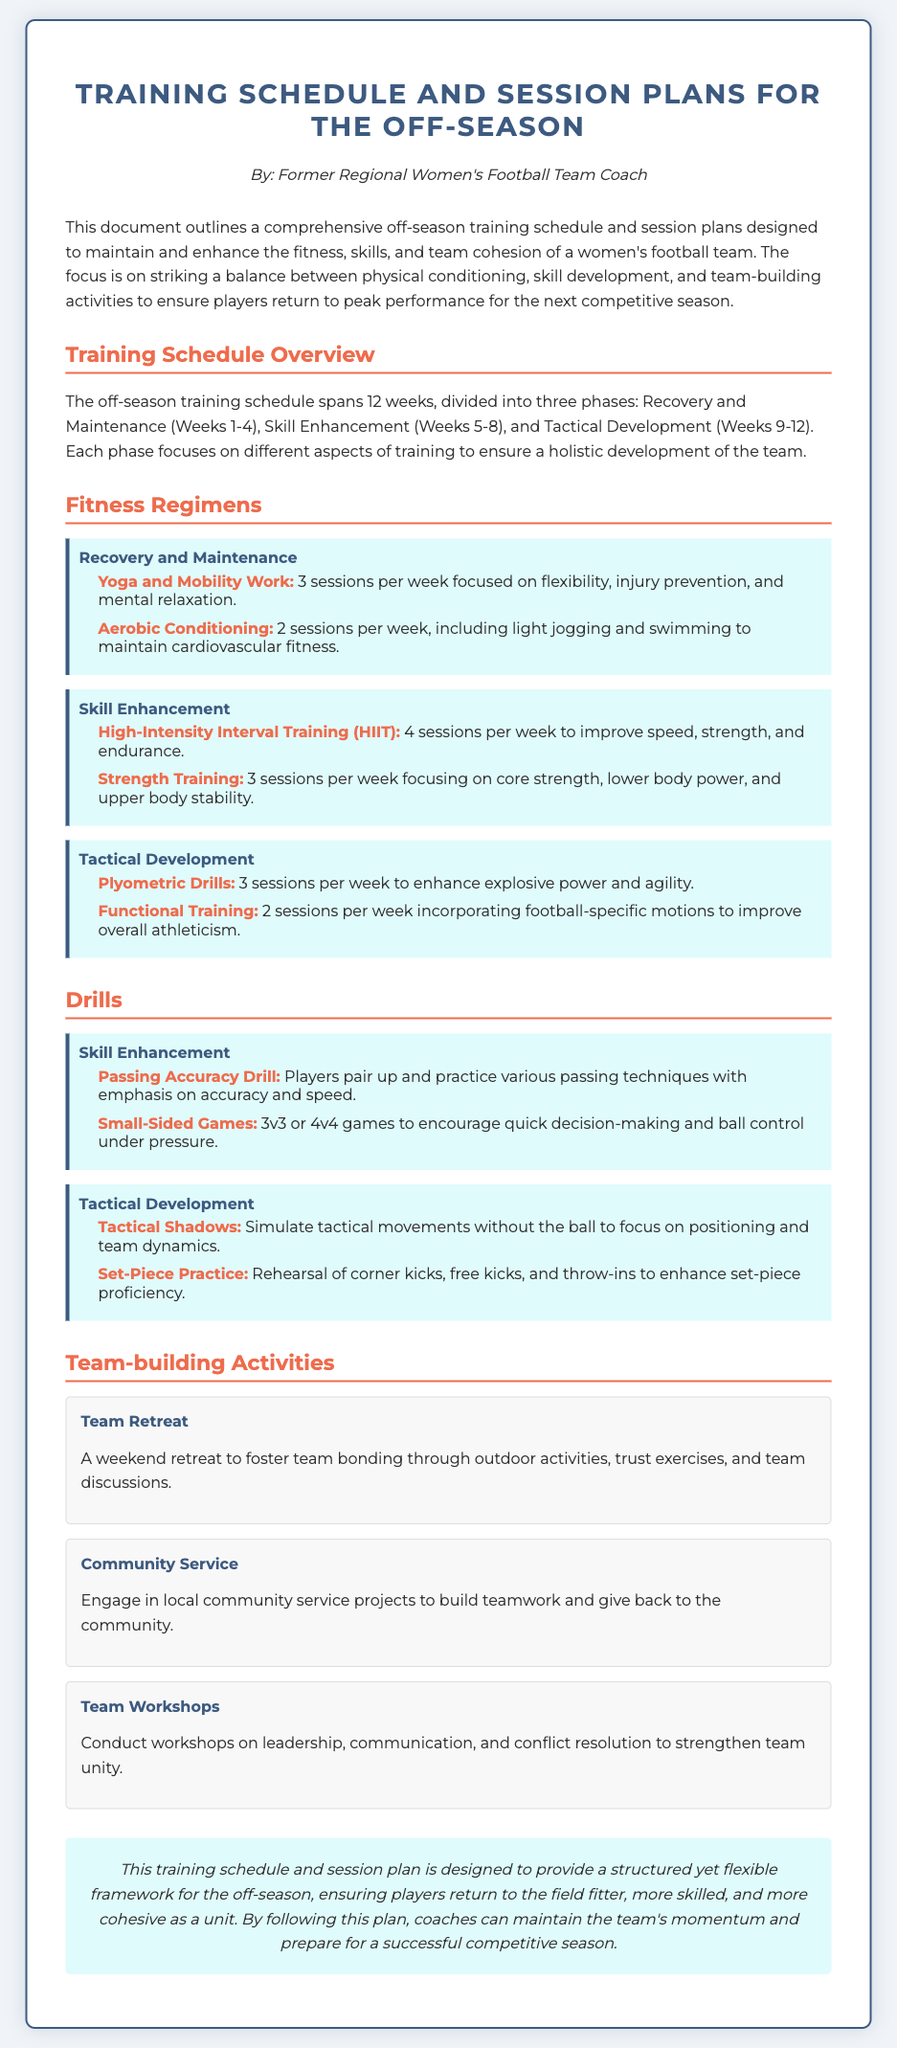What is the title of the document? The title of the document is stated at the top of the rendered document.
Answer: Training Schedule and Session Plans for the Off-Season Who authored the document? The author is mentioned below the title, indicating their background.
Answer: Former Regional Women's Football Team Coach How many phases are in the training schedule? The document outlines the training schedule split into three phases.
Answer: 3 What is the focus of the 'Recovery and Maintenance' phase? The document specifies the activities covered in this phase.
Answer: Flexibility, injury prevention, and mental relaxation How many sessions per week are dedicated to HIIT in the 'Skill Enhancement' phase? The document highlights the number of sessions for each activity in this phase.
Answer: 4 sessions Which activity involves outdoor team bonding? The document lists various team-building activities, including specific names.
Answer: Team Retreat What is a primary drill in the 'Tactical Development' phase? The document mentions drills categorized under each phase.
Answer: Tactical Shadows What type of training does 'Strength Training' focus on? The document specifies the training aims in this phase.
Answer: Core strength, lower body power, and upper body stability 